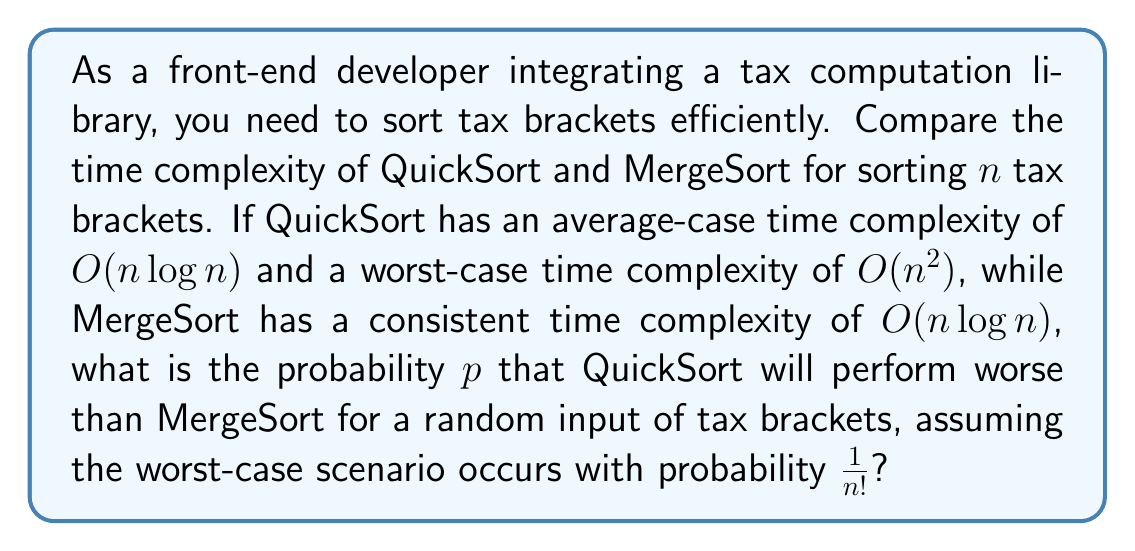Solve this math problem. To solve this problem, we need to follow these steps:

1) First, let's consider when QuickSort performs worse than MergeSort:
   This occurs in the worst-case scenario for QuickSort, which has a time complexity of $O(n^2)$.

2) The probability of this worst-case scenario occurring is given as $\frac{1}{n!}$.

3) In all other cases, QuickSort performs as well as MergeSort (both have $O(n \log n)$ time complexity).

4) Therefore, the probability $p$ that QuickSort performs worse than MergeSort is equal to the probability of the worst-case scenario occurring:

   $$p = \frac{1}{n!}$$

5) This probability decreases rapidly as $n$ increases, making it very unlikely for large numbers of tax brackets.

6) For example:
   - For $n = 5$, $p = \frac{1}{5!} = \frac{1}{120} \approx 0.0083$
   - For $n = 10$, $p = \frac{1}{10!} = \frac{1}{3,628,800} \approx 2.76 \times 10^{-7}$

This shows that for practical purposes, especially with a large number of tax brackets, QuickSort is very unlikely to perform worse than MergeSort.
Answer: $p = \frac{1}{n!}$ 